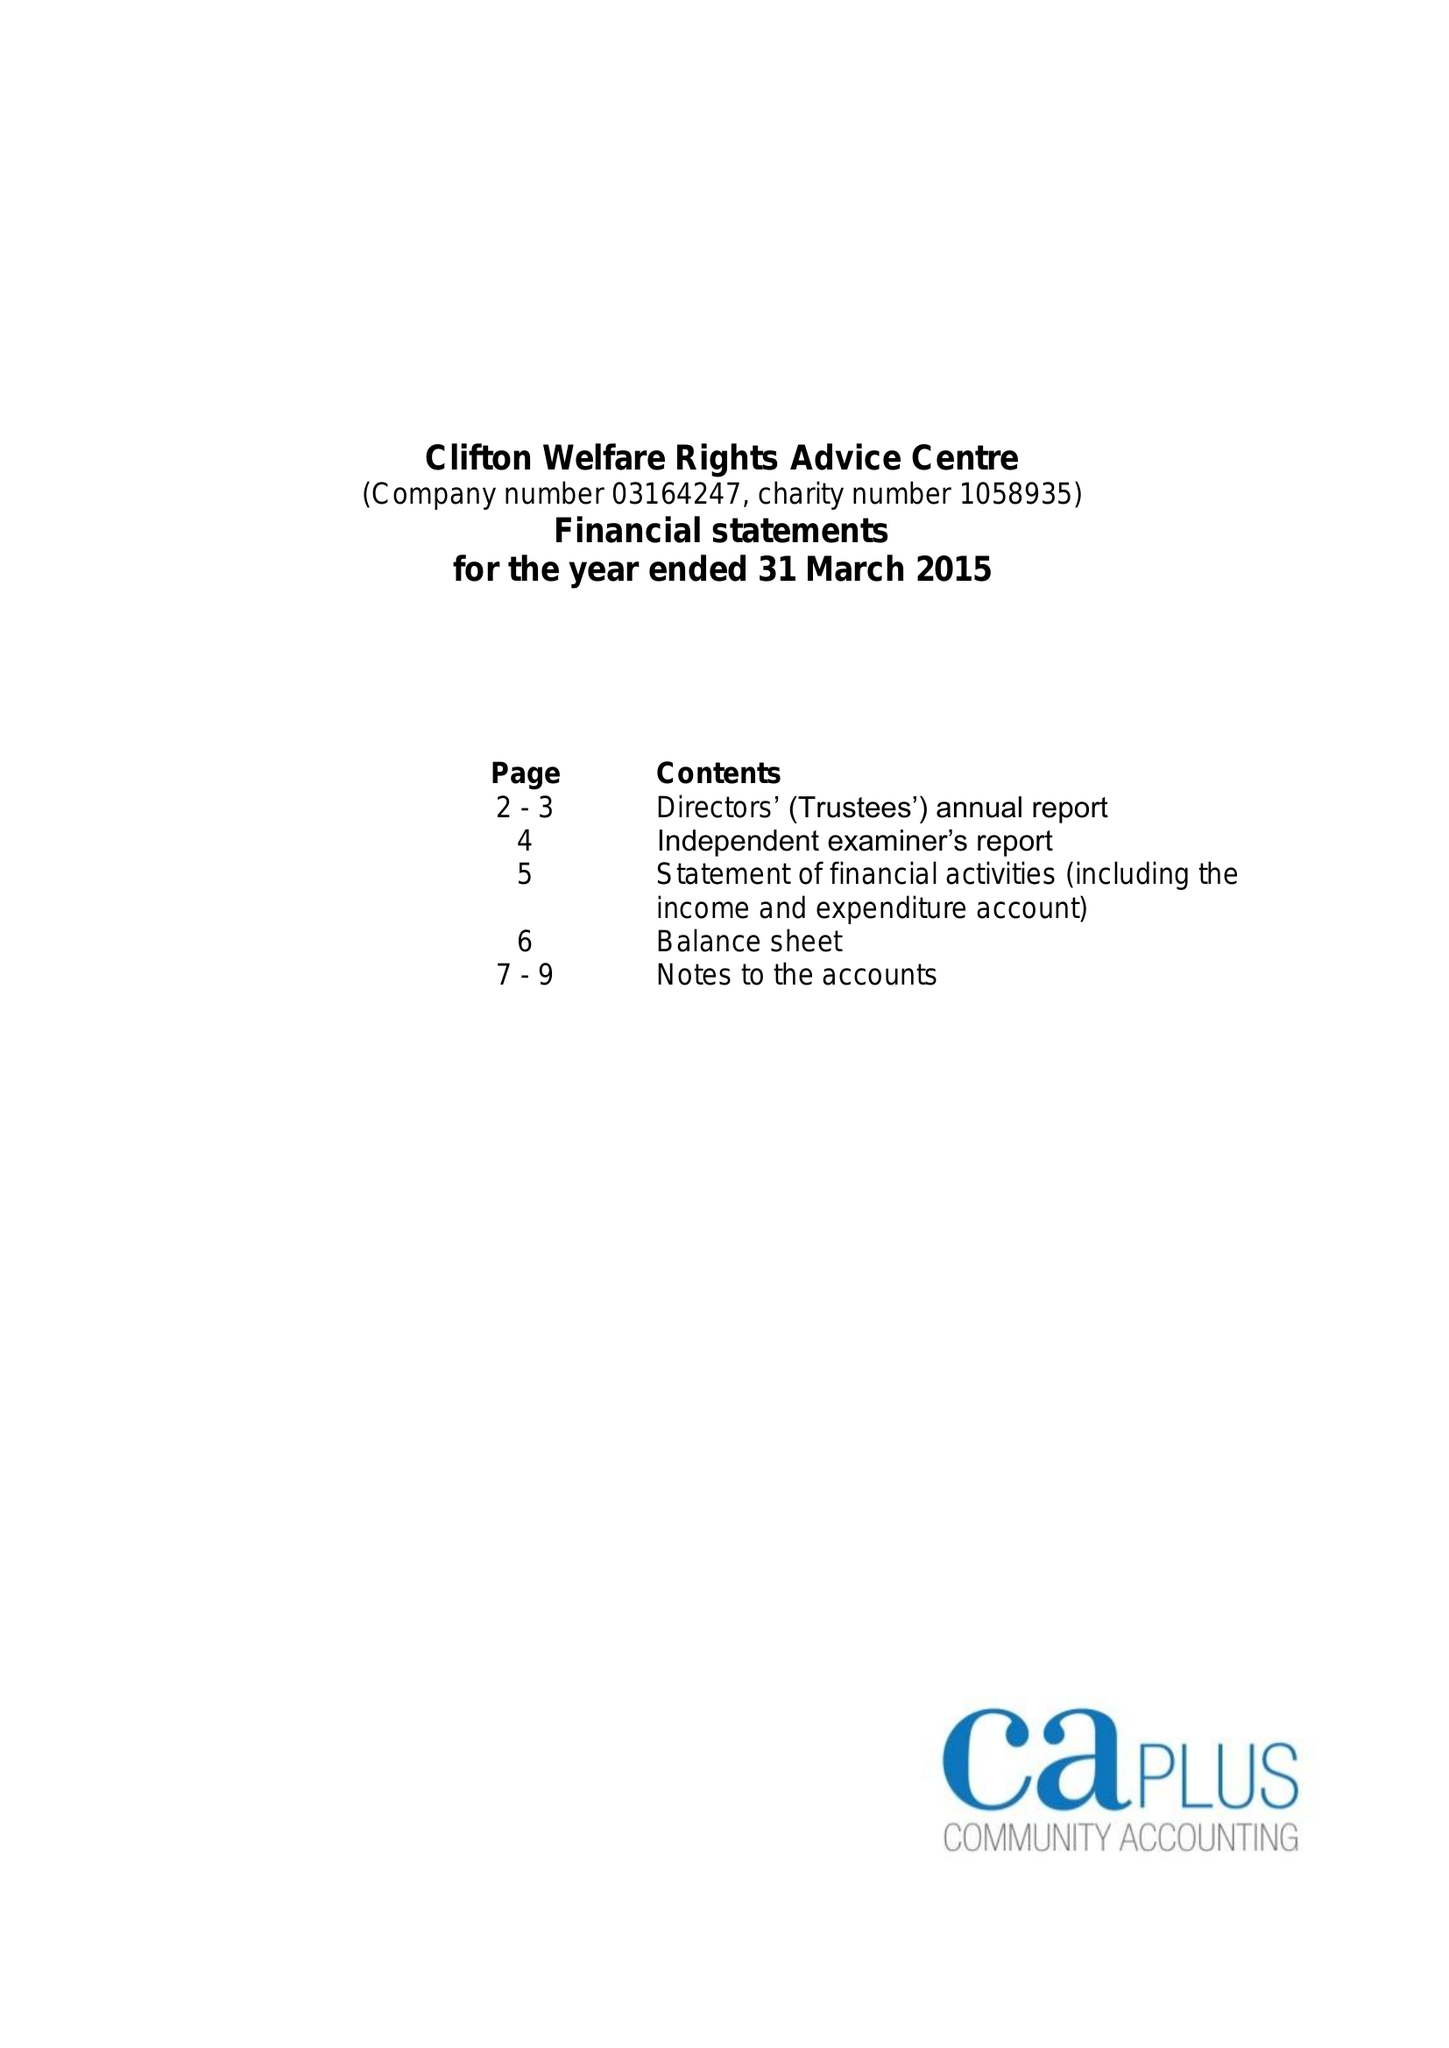What is the value for the income_annually_in_british_pounds?
Answer the question using a single word or phrase. 84092.00 